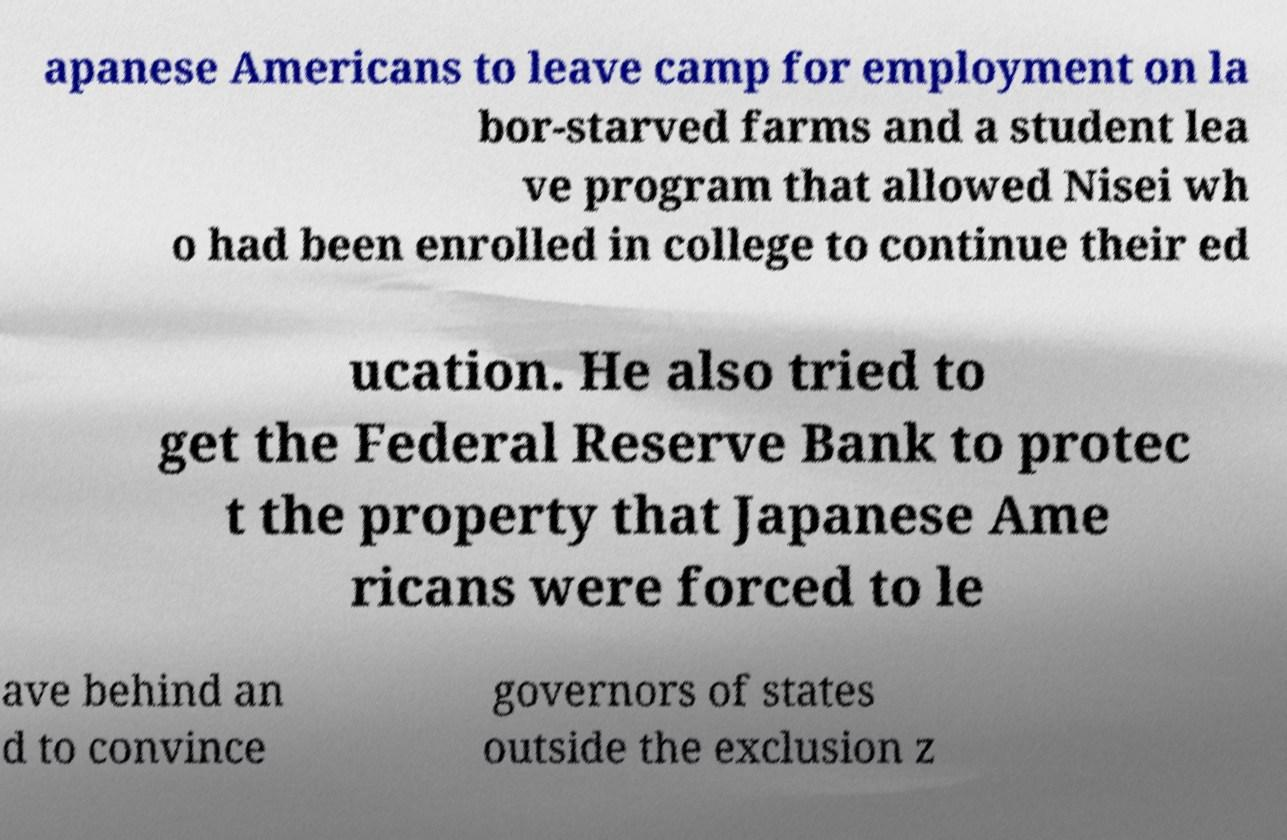Could you assist in decoding the text presented in this image and type it out clearly? apanese Americans to leave camp for employment on la bor-starved farms and a student lea ve program that allowed Nisei wh o had been enrolled in college to continue their ed ucation. He also tried to get the Federal Reserve Bank to protec t the property that Japanese Ame ricans were forced to le ave behind an d to convince governors of states outside the exclusion z 